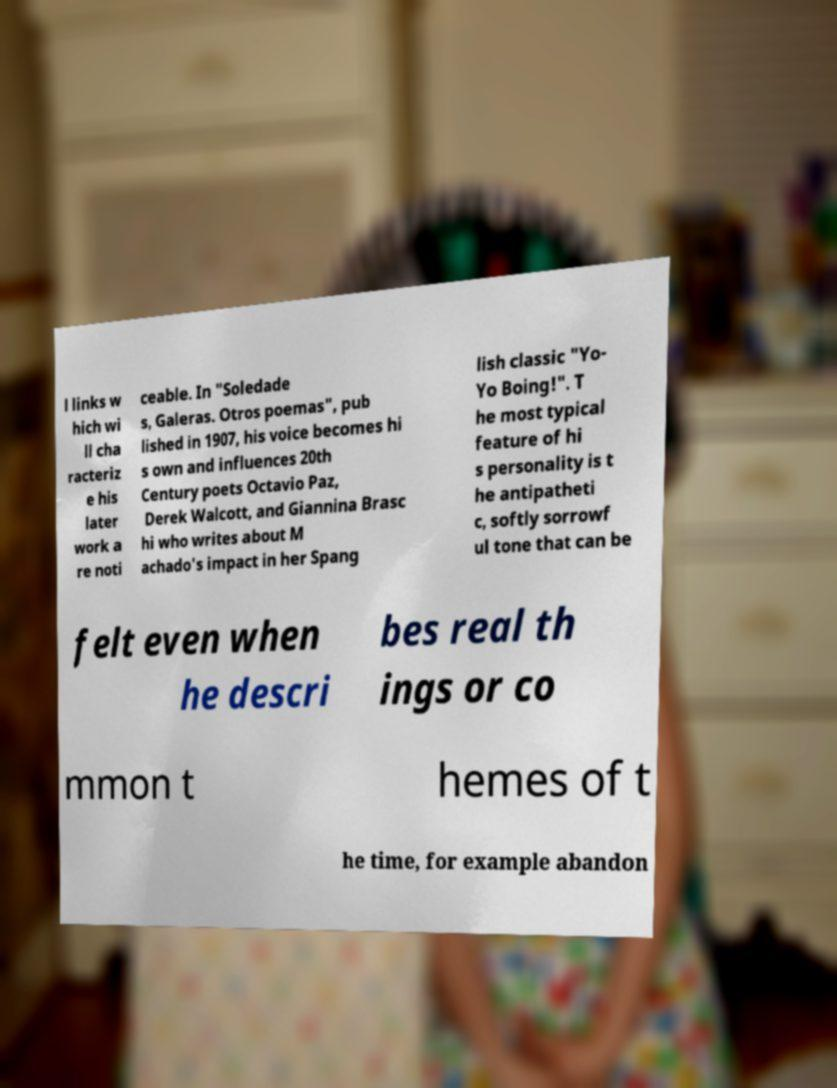Can you accurately transcribe the text from the provided image for me? l links w hich wi ll cha racteriz e his later work a re noti ceable. In "Soledade s, Galeras. Otros poemas", pub lished in 1907, his voice becomes hi s own and influences 20th Century poets Octavio Paz, Derek Walcott, and Giannina Brasc hi who writes about M achado's impact in her Spang lish classic "Yo- Yo Boing!". T he most typical feature of hi s personality is t he antipatheti c, softly sorrowf ul tone that can be felt even when he descri bes real th ings or co mmon t hemes of t he time, for example abandon 